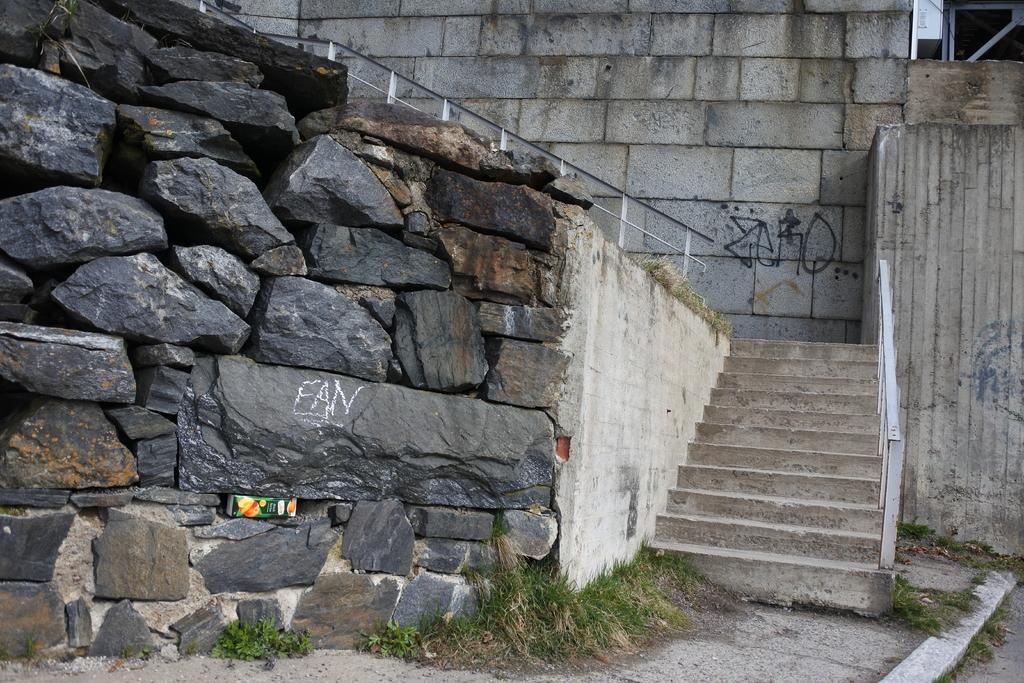What type of wall is visible in the image? There is a wall with rocks in the image. What architectural feature is located beside the wall? There are stairs beside the wall. What safety feature is associated with the stairs? There is a railing associated with the stairs. What type of wall is on top of the stairs? There is a wall with bricks on top of the stairs. What type of creature is seen climbing the wall in the image? There is no creature visible in the image; it only shows a wall with rocks, stairs, and a railing. Who is the partner of the person climbing the wall in the image? There is no person climbing the wall in the image, so there is no partner to identify. 